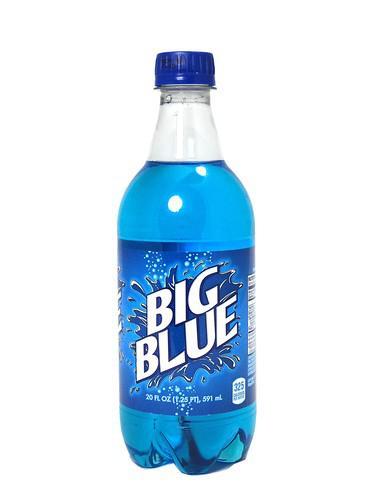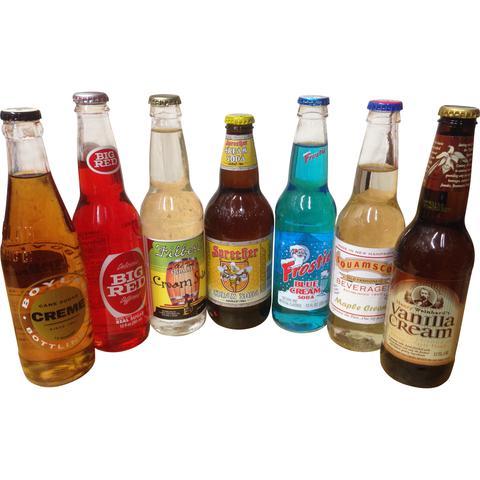The first image is the image on the left, the second image is the image on the right. For the images shown, is this caption "All bottles contain colored liquids and have labels and caps on." true? Answer yes or no. Yes. The first image is the image on the left, the second image is the image on the right. Evaluate the accuracy of this statement regarding the images: "There are no more than 3 bottles in the image on the left.". Is it true? Answer yes or no. Yes. 